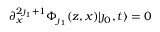Convert formula to latex. <formula><loc_0><loc_0><loc_500><loc_500>\partial _ { x } ^ { 2 \jmath _ { 1 } + 1 } \Phi _ { \jmath _ { 1 } } ( z , x ) | \jmath _ { 0 } , t \rangle = 0</formula> 